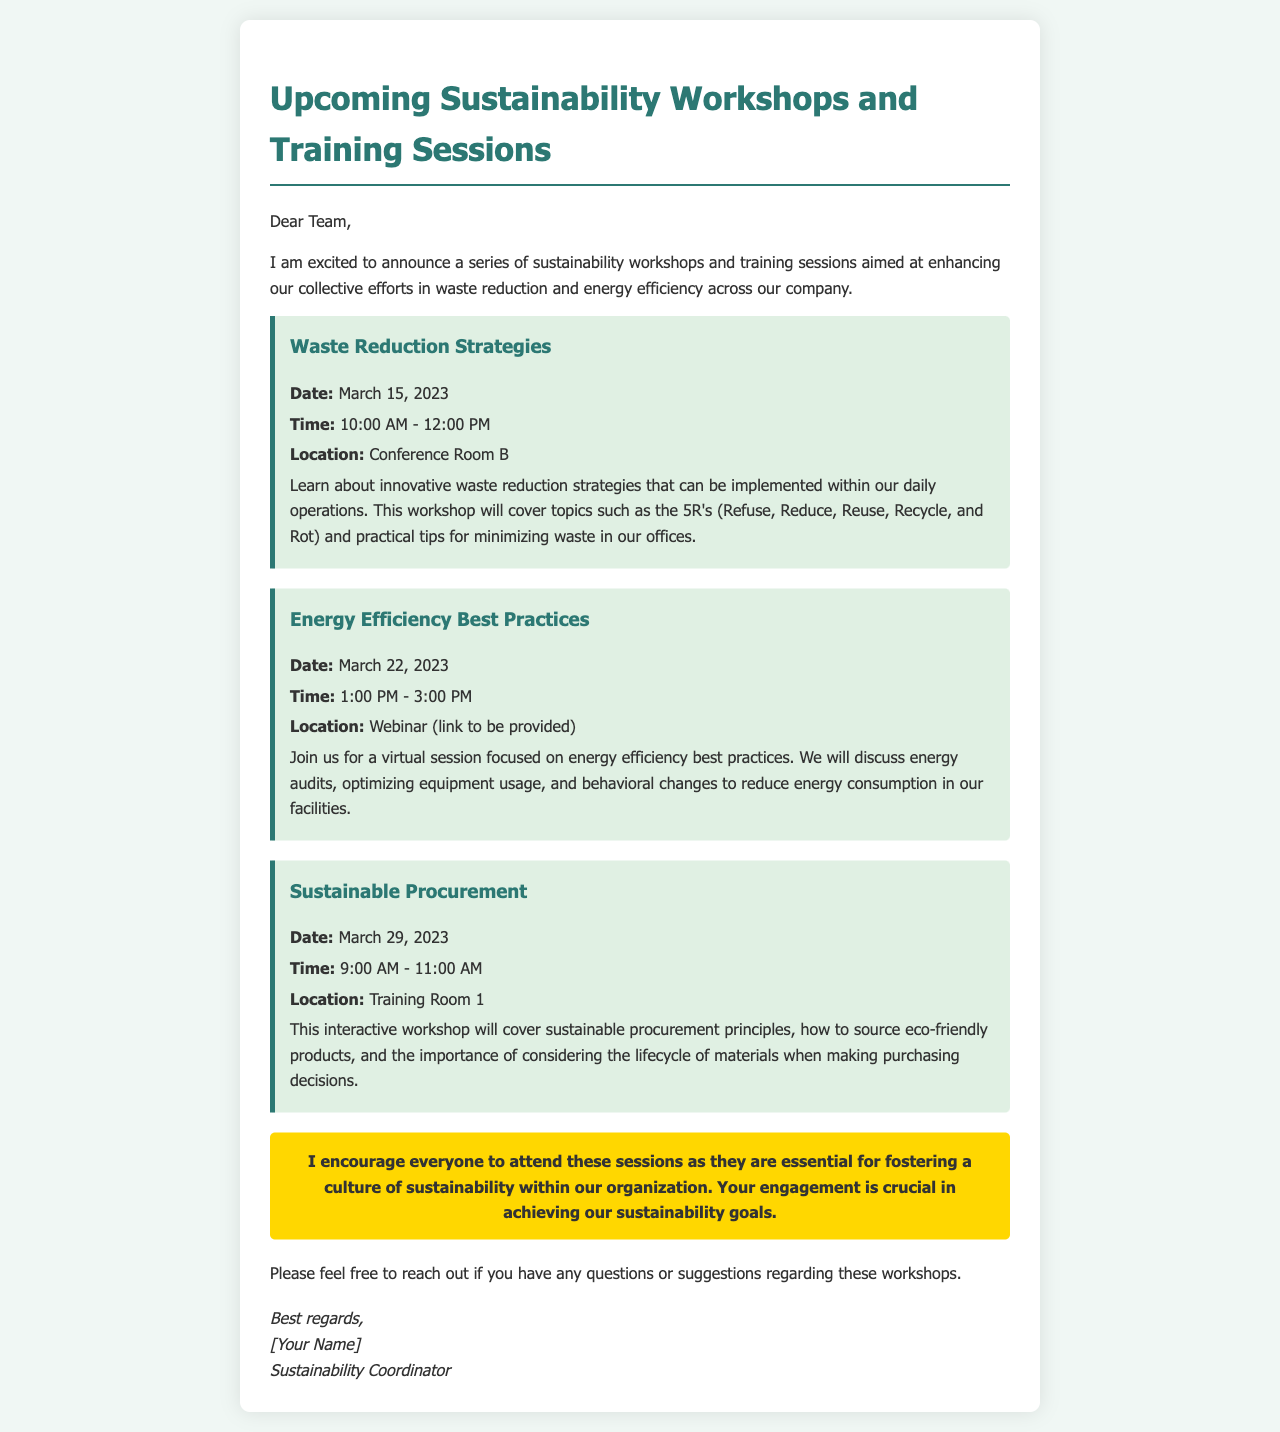What is the title of the document? The title is prominently displayed at the top of the letter, summarizing the main topic.
Answer: Upcoming Sustainability Workshops and Training Sessions Who is the sender of the letter? The sender's name appears at the end of the letter, indicating their position related to the content.
Answer: [Your Name] What is the date of the Waste Reduction Strategies workshop? The specific date of this workshop is provided in the description of the event.
Answer: March 15, 2023 Where will the Energy Efficiency Best Practices workshop take place? The location is specified in the workshop details for this particular session.
Answer: Webinar (link to be provided) What are the 5R's mentioned in the Waste Reduction Strategies workshop? This concept is mentioned as a key topic covered in the workshop description.
Answer: Refuse, Reduce, Reuse, Recycle, and Rot What time does the Sustainable Procurement workshop begin? The starting time is listed in the details of the workshop.
Answer: 9:00 AM Why are the workshops important for the organization? The letter explicitly states the significance of participation in achieving sustainability goals.
Answer: Essential for fostering a culture of sustainability How many workshops are outlined in the letter? The number of workshops can be counted from the sections provided within the document.
Answer: Three 